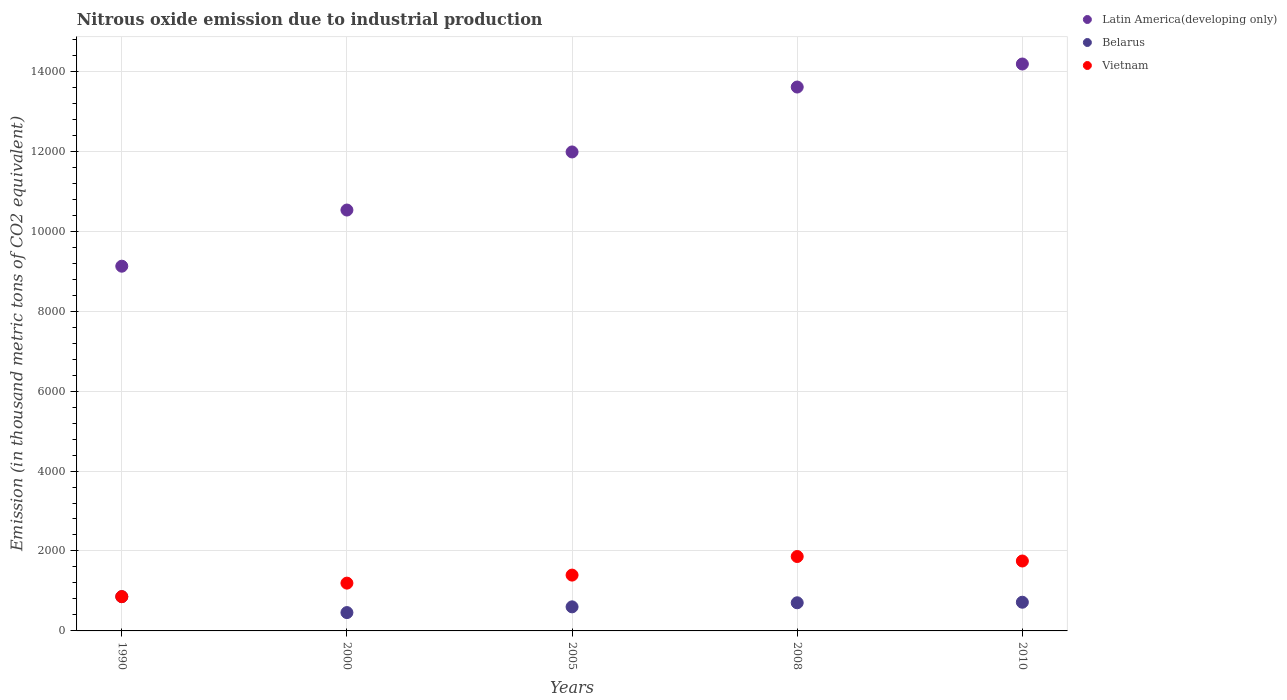How many different coloured dotlines are there?
Ensure brevity in your answer.  3. What is the amount of nitrous oxide emitted in Vietnam in 2010?
Make the answer very short. 1749.1. Across all years, what is the maximum amount of nitrous oxide emitted in Latin America(developing only)?
Your answer should be compact. 1.42e+04. Across all years, what is the minimum amount of nitrous oxide emitted in Vietnam?
Offer a very short reply. 857.4. In which year was the amount of nitrous oxide emitted in Vietnam maximum?
Give a very brief answer. 2008. What is the total amount of nitrous oxide emitted in Belarus in the graph?
Offer a terse response. 3339.7. What is the difference between the amount of nitrous oxide emitted in Latin America(developing only) in 2008 and that in 2010?
Your response must be concise. -576.2. What is the difference between the amount of nitrous oxide emitted in Latin America(developing only) in 2000 and the amount of nitrous oxide emitted in Vietnam in 1990?
Provide a succinct answer. 9671.2. What is the average amount of nitrous oxide emitted in Vietnam per year?
Your response must be concise. 1412.02. In the year 2010, what is the difference between the amount of nitrous oxide emitted in Vietnam and amount of nitrous oxide emitted in Belarus?
Your response must be concise. 1031.4. What is the ratio of the amount of nitrous oxide emitted in Latin America(developing only) in 1990 to that in 2005?
Keep it short and to the point. 0.76. Is the difference between the amount of nitrous oxide emitted in Vietnam in 2000 and 2005 greater than the difference between the amount of nitrous oxide emitted in Belarus in 2000 and 2005?
Provide a short and direct response. No. What is the difference between the highest and the second highest amount of nitrous oxide emitted in Belarus?
Provide a succinct answer. 139.3. What is the difference between the highest and the lowest amount of nitrous oxide emitted in Vietnam?
Provide a succinct answer. 1004.2. Is the sum of the amount of nitrous oxide emitted in Vietnam in 2005 and 2008 greater than the maximum amount of nitrous oxide emitted in Belarus across all years?
Provide a short and direct response. Yes. Is the amount of nitrous oxide emitted in Vietnam strictly less than the amount of nitrous oxide emitted in Latin America(developing only) over the years?
Your answer should be very brief. Yes. How many dotlines are there?
Make the answer very short. 3. How many years are there in the graph?
Give a very brief answer. 5. Are the values on the major ticks of Y-axis written in scientific E-notation?
Offer a terse response. No. Does the graph contain grids?
Make the answer very short. Yes. How many legend labels are there?
Provide a short and direct response. 3. What is the title of the graph?
Ensure brevity in your answer.  Nitrous oxide emission due to industrial production. What is the label or title of the X-axis?
Provide a short and direct response. Years. What is the label or title of the Y-axis?
Your response must be concise. Emission (in thousand metric tons of CO2 equivalent). What is the Emission (in thousand metric tons of CO2 equivalent) in Latin America(developing only) in 1990?
Offer a very short reply. 9123.8. What is the Emission (in thousand metric tons of CO2 equivalent) in Belarus in 1990?
Provide a short and direct response. 857. What is the Emission (in thousand metric tons of CO2 equivalent) in Vietnam in 1990?
Provide a short and direct response. 857.4. What is the Emission (in thousand metric tons of CO2 equivalent) of Latin America(developing only) in 2000?
Your answer should be compact. 1.05e+04. What is the Emission (in thousand metric tons of CO2 equivalent) of Belarus in 2000?
Your answer should be very brief. 458.8. What is the Emission (in thousand metric tons of CO2 equivalent) of Vietnam in 2000?
Keep it short and to the point. 1195.6. What is the Emission (in thousand metric tons of CO2 equivalent) in Latin America(developing only) in 2005?
Your answer should be very brief. 1.20e+04. What is the Emission (in thousand metric tons of CO2 equivalent) of Belarus in 2005?
Offer a terse response. 602.1. What is the Emission (in thousand metric tons of CO2 equivalent) of Vietnam in 2005?
Provide a short and direct response. 1396.4. What is the Emission (in thousand metric tons of CO2 equivalent) in Latin America(developing only) in 2008?
Provide a short and direct response. 1.36e+04. What is the Emission (in thousand metric tons of CO2 equivalent) of Belarus in 2008?
Provide a succinct answer. 704.1. What is the Emission (in thousand metric tons of CO2 equivalent) in Vietnam in 2008?
Keep it short and to the point. 1861.6. What is the Emission (in thousand metric tons of CO2 equivalent) in Latin America(developing only) in 2010?
Offer a terse response. 1.42e+04. What is the Emission (in thousand metric tons of CO2 equivalent) of Belarus in 2010?
Keep it short and to the point. 717.7. What is the Emission (in thousand metric tons of CO2 equivalent) of Vietnam in 2010?
Make the answer very short. 1749.1. Across all years, what is the maximum Emission (in thousand metric tons of CO2 equivalent) in Latin America(developing only)?
Keep it short and to the point. 1.42e+04. Across all years, what is the maximum Emission (in thousand metric tons of CO2 equivalent) of Belarus?
Your answer should be very brief. 857. Across all years, what is the maximum Emission (in thousand metric tons of CO2 equivalent) of Vietnam?
Keep it short and to the point. 1861.6. Across all years, what is the minimum Emission (in thousand metric tons of CO2 equivalent) of Latin America(developing only)?
Ensure brevity in your answer.  9123.8. Across all years, what is the minimum Emission (in thousand metric tons of CO2 equivalent) in Belarus?
Make the answer very short. 458.8. Across all years, what is the minimum Emission (in thousand metric tons of CO2 equivalent) of Vietnam?
Keep it short and to the point. 857.4. What is the total Emission (in thousand metric tons of CO2 equivalent) of Latin America(developing only) in the graph?
Keep it short and to the point. 5.94e+04. What is the total Emission (in thousand metric tons of CO2 equivalent) of Belarus in the graph?
Keep it short and to the point. 3339.7. What is the total Emission (in thousand metric tons of CO2 equivalent) of Vietnam in the graph?
Your response must be concise. 7060.1. What is the difference between the Emission (in thousand metric tons of CO2 equivalent) in Latin America(developing only) in 1990 and that in 2000?
Make the answer very short. -1404.8. What is the difference between the Emission (in thousand metric tons of CO2 equivalent) of Belarus in 1990 and that in 2000?
Your answer should be very brief. 398.2. What is the difference between the Emission (in thousand metric tons of CO2 equivalent) in Vietnam in 1990 and that in 2000?
Give a very brief answer. -338.2. What is the difference between the Emission (in thousand metric tons of CO2 equivalent) in Latin America(developing only) in 1990 and that in 2005?
Your answer should be very brief. -2858. What is the difference between the Emission (in thousand metric tons of CO2 equivalent) of Belarus in 1990 and that in 2005?
Your answer should be very brief. 254.9. What is the difference between the Emission (in thousand metric tons of CO2 equivalent) of Vietnam in 1990 and that in 2005?
Provide a short and direct response. -539. What is the difference between the Emission (in thousand metric tons of CO2 equivalent) of Latin America(developing only) in 1990 and that in 2008?
Offer a terse response. -4481.8. What is the difference between the Emission (in thousand metric tons of CO2 equivalent) of Belarus in 1990 and that in 2008?
Your answer should be very brief. 152.9. What is the difference between the Emission (in thousand metric tons of CO2 equivalent) in Vietnam in 1990 and that in 2008?
Offer a very short reply. -1004.2. What is the difference between the Emission (in thousand metric tons of CO2 equivalent) in Latin America(developing only) in 1990 and that in 2010?
Your response must be concise. -5058. What is the difference between the Emission (in thousand metric tons of CO2 equivalent) of Belarus in 1990 and that in 2010?
Offer a very short reply. 139.3. What is the difference between the Emission (in thousand metric tons of CO2 equivalent) of Vietnam in 1990 and that in 2010?
Make the answer very short. -891.7. What is the difference between the Emission (in thousand metric tons of CO2 equivalent) in Latin America(developing only) in 2000 and that in 2005?
Your answer should be compact. -1453.2. What is the difference between the Emission (in thousand metric tons of CO2 equivalent) in Belarus in 2000 and that in 2005?
Make the answer very short. -143.3. What is the difference between the Emission (in thousand metric tons of CO2 equivalent) of Vietnam in 2000 and that in 2005?
Provide a short and direct response. -200.8. What is the difference between the Emission (in thousand metric tons of CO2 equivalent) of Latin America(developing only) in 2000 and that in 2008?
Make the answer very short. -3077. What is the difference between the Emission (in thousand metric tons of CO2 equivalent) in Belarus in 2000 and that in 2008?
Give a very brief answer. -245.3. What is the difference between the Emission (in thousand metric tons of CO2 equivalent) of Vietnam in 2000 and that in 2008?
Make the answer very short. -666. What is the difference between the Emission (in thousand metric tons of CO2 equivalent) in Latin America(developing only) in 2000 and that in 2010?
Your answer should be very brief. -3653.2. What is the difference between the Emission (in thousand metric tons of CO2 equivalent) in Belarus in 2000 and that in 2010?
Offer a very short reply. -258.9. What is the difference between the Emission (in thousand metric tons of CO2 equivalent) in Vietnam in 2000 and that in 2010?
Ensure brevity in your answer.  -553.5. What is the difference between the Emission (in thousand metric tons of CO2 equivalent) of Latin America(developing only) in 2005 and that in 2008?
Your answer should be very brief. -1623.8. What is the difference between the Emission (in thousand metric tons of CO2 equivalent) in Belarus in 2005 and that in 2008?
Ensure brevity in your answer.  -102. What is the difference between the Emission (in thousand metric tons of CO2 equivalent) in Vietnam in 2005 and that in 2008?
Keep it short and to the point. -465.2. What is the difference between the Emission (in thousand metric tons of CO2 equivalent) in Latin America(developing only) in 2005 and that in 2010?
Provide a succinct answer. -2200. What is the difference between the Emission (in thousand metric tons of CO2 equivalent) in Belarus in 2005 and that in 2010?
Keep it short and to the point. -115.6. What is the difference between the Emission (in thousand metric tons of CO2 equivalent) of Vietnam in 2005 and that in 2010?
Ensure brevity in your answer.  -352.7. What is the difference between the Emission (in thousand metric tons of CO2 equivalent) of Latin America(developing only) in 2008 and that in 2010?
Offer a terse response. -576.2. What is the difference between the Emission (in thousand metric tons of CO2 equivalent) of Belarus in 2008 and that in 2010?
Your answer should be compact. -13.6. What is the difference between the Emission (in thousand metric tons of CO2 equivalent) in Vietnam in 2008 and that in 2010?
Provide a succinct answer. 112.5. What is the difference between the Emission (in thousand metric tons of CO2 equivalent) of Latin America(developing only) in 1990 and the Emission (in thousand metric tons of CO2 equivalent) of Belarus in 2000?
Offer a terse response. 8665. What is the difference between the Emission (in thousand metric tons of CO2 equivalent) of Latin America(developing only) in 1990 and the Emission (in thousand metric tons of CO2 equivalent) of Vietnam in 2000?
Keep it short and to the point. 7928.2. What is the difference between the Emission (in thousand metric tons of CO2 equivalent) in Belarus in 1990 and the Emission (in thousand metric tons of CO2 equivalent) in Vietnam in 2000?
Offer a very short reply. -338.6. What is the difference between the Emission (in thousand metric tons of CO2 equivalent) of Latin America(developing only) in 1990 and the Emission (in thousand metric tons of CO2 equivalent) of Belarus in 2005?
Your answer should be compact. 8521.7. What is the difference between the Emission (in thousand metric tons of CO2 equivalent) in Latin America(developing only) in 1990 and the Emission (in thousand metric tons of CO2 equivalent) in Vietnam in 2005?
Your answer should be compact. 7727.4. What is the difference between the Emission (in thousand metric tons of CO2 equivalent) of Belarus in 1990 and the Emission (in thousand metric tons of CO2 equivalent) of Vietnam in 2005?
Offer a very short reply. -539.4. What is the difference between the Emission (in thousand metric tons of CO2 equivalent) of Latin America(developing only) in 1990 and the Emission (in thousand metric tons of CO2 equivalent) of Belarus in 2008?
Provide a succinct answer. 8419.7. What is the difference between the Emission (in thousand metric tons of CO2 equivalent) of Latin America(developing only) in 1990 and the Emission (in thousand metric tons of CO2 equivalent) of Vietnam in 2008?
Make the answer very short. 7262.2. What is the difference between the Emission (in thousand metric tons of CO2 equivalent) of Belarus in 1990 and the Emission (in thousand metric tons of CO2 equivalent) of Vietnam in 2008?
Your response must be concise. -1004.6. What is the difference between the Emission (in thousand metric tons of CO2 equivalent) in Latin America(developing only) in 1990 and the Emission (in thousand metric tons of CO2 equivalent) in Belarus in 2010?
Offer a terse response. 8406.1. What is the difference between the Emission (in thousand metric tons of CO2 equivalent) of Latin America(developing only) in 1990 and the Emission (in thousand metric tons of CO2 equivalent) of Vietnam in 2010?
Give a very brief answer. 7374.7. What is the difference between the Emission (in thousand metric tons of CO2 equivalent) in Belarus in 1990 and the Emission (in thousand metric tons of CO2 equivalent) in Vietnam in 2010?
Provide a succinct answer. -892.1. What is the difference between the Emission (in thousand metric tons of CO2 equivalent) of Latin America(developing only) in 2000 and the Emission (in thousand metric tons of CO2 equivalent) of Belarus in 2005?
Make the answer very short. 9926.5. What is the difference between the Emission (in thousand metric tons of CO2 equivalent) in Latin America(developing only) in 2000 and the Emission (in thousand metric tons of CO2 equivalent) in Vietnam in 2005?
Offer a terse response. 9132.2. What is the difference between the Emission (in thousand metric tons of CO2 equivalent) of Belarus in 2000 and the Emission (in thousand metric tons of CO2 equivalent) of Vietnam in 2005?
Your response must be concise. -937.6. What is the difference between the Emission (in thousand metric tons of CO2 equivalent) of Latin America(developing only) in 2000 and the Emission (in thousand metric tons of CO2 equivalent) of Belarus in 2008?
Your answer should be compact. 9824.5. What is the difference between the Emission (in thousand metric tons of CO2 equivalent) in Latin America(developing only) in 2000 and the Emission (in thousand metric tons of CO2 equivalent) in Vietnam in 2008?
Offer a terse response. 8667. What is the difference between the Emission (in thousand metric tons of CO2 equivalent) in Belarus in 2000 and the Emission (in thousand metric tons of CO2 equivalent) in Vietnam in 2008?
Ensure brevity in your answer.  -1402.8. What is the difference between the Emission (in thousand metric tons of CO2 equivalent) in Latin America(developing only) in 2000 and the Emission (in thousand metric tons of CO2 equivalent) in Belarus in 2010?
Your answer should be compact. 9810.9. What is the difference between the Emission (in thousand metric tons of CO2 equivalent) of Latin America(developing only) in 2000 and the Emission (in thousand metric tons of CO2 equivalent) of Vietnam in 2010?
Your answer should be compact. 8779.5. What is the difference between the Emission (in thousand metric tons of CO2 equivalent) in Belarus in 2000 and the Emission (in thousand metric tons of CO2 equivalent) in Vietnam in 2010?
Your answer should be very brief. -1290.3. What is the difference between the Emission (in thousand metric tons of CO2 equivalent) of Latin America(developing only) in 2005 and the Emission (in thousand metric tons of CO2 equivalent) of Belarus in 2008?
Offer a terse response. 1.13e+04. What is the difference between the Emission (in thousand metric tons of CO2 equivalent) in Latin America(developing only) in 2005 and the Emission (in thousand metric tons of CO2 equivalent) in Vietnam in 2008?
Offer a terse response. 1.01e+04. What is the difference between the Emission (in thousand metric tons of CO2 equivalent) of Belarus in 2005 and the Emission (in thousand metric tons of CO2 equivalent) of Vietnam in 2008?
Ensure brevity in your answer.  -1259.5. What is the difference between the Emission (in thousand metric tons of CO2 equivalent) of Latin America(developing only) in 2005 and the Emission (in thousand metric tons of CO2 equivalent) of Belarus in 2010?
Offer a very short reply. 1.13e+04. What is the difference between the Emission (in thousand metric tons of CO2 equivalent) of Latin America(developing only) in 2005 and the Emission (in thousand metric tons of CO2 equivalent) of Vietnam in 2010?
Ensure brevity in your answer.  1.02e+04. What is the difference between the Emission (in thousand metric tons of CO2 equivalent) in Belarus in 2005 and the Emission (in thousand metric tons of CO2 equivalent) in Vietnam in 2010?
Your response must be concise. -1147. What is the difference between the Emission (in thousand metric tons of CO2 equivalent) in Latin America(developing only) in 2008 and the Emission (in thousand metric tons of CO2 equivalent) in Belarus in 2010?
Your answer should be compact. 1.29e+04. What is the difference between the Emission (in thousand metric tons of CO2 equivalent) in Latin America(developing only) in 2008 and the Emission (in thousand metric tons of CO2 equivalent) in Vietnam in 2010?
Give a very brief answer. 1.19e+04. What is the difference between the Emission (in thousand metric tons of CO2 equivalent) of Belarus in 2008 and the Emission (in thousand metric tons of CO2 equivalent) of Vietnam in 2010?
Provide a short and direct response. -1045. What is the average Emission (in thousand metric tons of CO2 equivalent) of Latin America(developing only) per year?
Provide a succinct answer. 1.19e+04. What is the average Emission (in thousand metric tons of CO2 equivalent) in Belarus per year?
Your answer should be very brief. 667.94. What is the average Emission (in thousand metric tons of CO2 equivalent) in Vietnam per year?
Your answer should be compact. 1412.02. In the year 1990, what is the difference between the Emission (in thousand metric tons of CO2 equivalent) in Latin America(developing only) and Emission (in thousand metric tons of CO2 equivalent) in Belarus?
Give a very brief answer. 8266.8. In the year 1990, what is the difference between the Emission (in thousand metric tons of CO2 equivalent) in Latin America(developing only) and Emission (in thousand metric tons of CO2 equivalent) in Vietnam?
Provide a succinct answer. 8266.4. In the year 2000, what is the difference between the Emission (in thousand metric tons of CO2 equivalent) in Latin America(developing only) and Emission (in thousand metric tons of CO2 equivalent) in Belarus?
Provide a short and direct response. 1.01e+04. In the year 2000, what is the difference between the Emission (in thousand metric tons of CO2 equivalent) of Latin America(developing only) and Emission (in thousand metric tons of CO2 equivalent) of Vietnam?
Your response must be concise. 9333. In the year 2000, what is the difference between the Emission (in thousand metric tons of CO2 equivalent) of Belarus and Emission (in thousand metric tons of CO2 equivalent) of Vietnam?
Make the answer very short. -736.8. In the year 2005, what is the difference between the Emission (in thousand metric tons of CO2 equivalent) of Latin America(developing only) and Emission (in thousand metric tons of CO2 equivalent) of Belarus?
Your response must be concise. 1.14e+04. In the year 2005, what is the difference between the Emission (in thousand metric tons of CO2 equivalent) in Latin America(developing only) and Emission (in thousand metric tons of CO2 equivalent) in Vietnam?
Provide a succinct answer. 1.06e+04. In the year 2005, what is the difference between the Emission (in thousand metric tons of CO2 equivalent) of Belarus and Emission (in thousand metric tons of CO2 equivalent) of Vietnam?
Make the answer very short. -794.3. In the year 2008, what is the difference between the Emission (in thousand metric tons of CO2 equivalent) in Latin America(developing only) and Emission (in thousand metric tons of CO2 equivalent) in Belarus?
Provide a short and direct response. 1.29e+04. In the year 2008, what is the difference between the Emission (in thousand metric tons of CO2 equivalent) of Latin America(developing only) and Emission (in thousand metric tons of CO2 equivalent) of Vietnam?
Ensure brevity in your answer.  1.17e+04. In the year 2008, what is the difference between the Emission (in thousand metric tons of CO2 equivalent) of Belarus and Emission (in thousand metric tons of CO2 equivalent) of Vietnam?
Offer a terse response. -1157.5. In the year 2010, what is the difference between the Emission (in thousand metric tons of CO2 equivalent) in Latin America(developing only) and Emission (in thousand metric tons of CO2 equivalent) in Belarus?
Give a very brief answer. 1.35e+04. In the year 2010, what is the difference between the Emission (in thousand metric tons of CO2 equivalent) of Latin America(developing only) and Emission (in thousand metric tons of CO2 equivalent) of Vietnam?
Your answer should be compact. 1.24e+04. In the year 2010, what is the difference between the Emission (in thousand metric tons of CO2 equivalent) in Belarus and Emission (in thousand metric tons of CO2 equivalent) in Vietnam?
Offer a terse response. -1031.4. What is the ratio of the Emission (in thousand metric tons of CO2 equivalent) of Latin America(developing only) in 1990 to that in 2000?
Your response must be concise. 0.87. What is the ratio of the Emission (in thousand metric tons of CO2 equivalent) in Belarus in 1990 to that in 2000?
Give a very brief answer. 1.87. What is the ratio of the Emission (in thousand metric tons of CO2 equivalent) of Vietnam in 1990 to that in 2000?
Your response must be concise. 0.72. What is the ratio of the Emission (in thousand metric tons of CO2 equivalent) in Latin America(developing only) in 1990 to that in 2005?
Make the answer very short. 0.76. What is the ratio of the Emission (in thousand metric tons of CO2 equivalent) in Belarus in 1990 to that in 2005?
Your response must be concise. 1.42. What is the ratio of the Emission (in thousand metric tons of CO2 equivalent) in Vietnam in 1990 to that in 2005?
Keep it short and to the point. 0.61. What is the ratio of the Emission (in thousand metric tons of CO2 equivalent) in Latin America(developing only) in 1990 to that in 2008?
Provide a short and direct response. 0.67. What is the ratio of the Emission (in thousand metric tons of CO2 equivalent) of Belarus in 1990 to that in 2008?
Provide a short and direct response. 1.22. What is the ratio of the Emission (in thousand metric tons of CO2 equivalent) in Vietnam in 1990 to that in 2008?
Your answer should be compact. 0.46. What is the ratio of the Emission (in thousand metric tons of CO2 equivalent) in Latin America(developing only) in 1990 to that in 2010?
Provide a succinct answer. 0.64. What is the ratio of the Emission (in thousand metric tons of CO2 equivalent) in Belarus in 1990 to that in 2010?
Offer a very short reply. 1.19. What is the ratio of the Emission (in thousand metric tons of CO2 equivalent) in Vietnam in 1990 to that in 2010?
Your response must be concise. 0.49. What is the ratio of the Emission (in thousand metric tons of CO2 equivalent) of Latin America(developing only) in 2000 to that in 2005?
Your answer should be very brief. 0.88. What is the ratio of the Emission (in thousand metric tons of CO2 equivalent) in Belarus in 2000 to that in 2005?
Offer a terse response. 0.76. What is the ratio of the Emission (in thousand metric tons of CO2 equivalent) of Vietnam in 2000 to that in 2005?
Offer a very short reply. 0.86. What is the ratio of the Emission (in thousand metric tons of CO2 equivalent) of Latin America(developing only) in 2000 to that in 2008?
Make the answer very short. 0.77. What is the ratio of the Emission (in thousand metric tons of CO2 equivalent) in Belarus in 2000 to that in 2008?
Your answer should be very brief. 0.65. What is the ratio of the Emission (in thousand metric tons of CO2 equivalent) of Vietnam in 2000 to that in 2008?
Make the answer very short. 0.64. What is the ratio of the Emission (in thousand metric tons of CO2 equivalent) of Latin America(developing only) in 2000 to that in 2010?
Your answer should be very brief. 0.74. What is the ratio of the Emission (in thousand metric tons of CO2 equivalent) of Belarus in 2000 to that in 2010?
Ensure brevity in your answer.  0.64. What is the ratio of the Emission (in thousand metric tons of CO2 equivalent) of Vietnam in 2000 to that in 2010?
Your answer should be very brief. 0.68. What is the ratio of the Emission (in thousand metric tons of CO2 equivalent) in Latin America(developing only) in 2005 to that in 2008?
Give a very brief answer. 0.88. What is the ratio of the Emission (in thousand metric tons of CO2 equivalent) of Belarus in 2005 to that in 2008?
Your response must be concise. 0.86. What is the ratio of the Emission (in thousand metric tons of CO2 equivalent) of Vietnam in 2005 to that in 2008?
Make the answer very short. 0.75. What is the ratio of the Emission (in thousand metric tons of CO2 equivalent) in Latin America(developing only) in 2005 to that in 2010?
Offer a terse response. 0.84. What is the ratio of the Emission (in thousand metric tons of CO2 equivalent) of Belarus in 2005 to that in 2010?
Offer a terse response. 0.84. What is the ratio of the Emission (in thousand metric tons of CO2 equivalent) of Vietnam in 2005 to that in 2010?
Provide a succinct answer. 0.8. What is the ratio of the Emission (in thousand metric tons of CO2 equivalent) in Latin America(developing only) in 2008 to that in 2010?
Provide a succinct answer. 0.96. What is the ratio of the Emission (in thousand metric tons of CO2 equivalent) of Belarus in 2008 to that in 2010?
Ensure brevity in your answer.  0.98. What is the ratio of the Emission (in thousand metric tons of CO2 equivalent) of Vietnam in 2008 to that in 2010?
Provide a succinct answer. 1.06. What is the difference between the highest and the second highest Emission (in thousand metric tons of CO2 equivalent) in Latin America(developing only)?
Your answer should be compact. 576.2. What is the difference between the highest and the second highest Emission (in thousand metric tons of CO2 equivalent) in Belarus?
Your response must be concise. 139.3. What is the difference between the highest and the second highest Emission (in thousand metric tons of CO2 equivalent) of Vietnam?
Offer a terse response. 112.5. What is the difference between the highest and the lowest Emission (in thousand metric tons of CO2 equivalent) in Latin America(developing only)?
Your answer should be compact. 5058. What is the difference between the highest and the lowest Emission (in thousand metric tons of CO2 equivalent) in Belarus?
Provide a short and direct response. 398.2. What is the difference between the highest and the lowest Emission (in thousand metric tons of CO2 equivalent) of Vietnam?
Your answer should be very brief. 1004.2. 